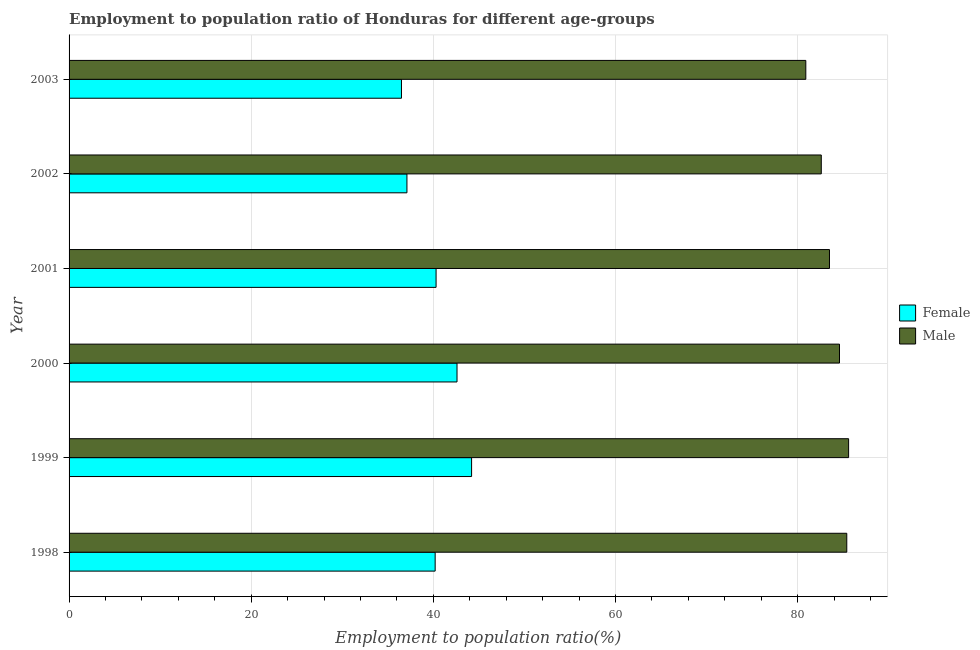How many different coloured bars are there?
Ensure brevity in your answer.  2. How many groups of bars are there?
Offer a terse response. 6. Are the number of bars per tick equal to the number of legend labels?
Offer a very short reply. Yes. How many bars are there on the 6th tick from the top?
Ensure brevity in your answer.  2. In how many cases, is the number of bars for a given year not equal to the number of legend labels?
Ensure brevity in your answer.  0. What is the employment to population ratio(male) in 1998?
Offer a terse response. 85.4. Across all years, what is the maximum employment to population ratio(female)?
Provide a succinct answer. 44.2. Across all years, what is the minimum employment to population ratio(female)?
Your answer should be compact. 36.5. In which year was the employment to population ratio(female) minimum?
Provide a succinct answer. 2003. What is the total employment to population ratio(male) in the graph?
Provide a short and direct response. 502.6. What is the difference between the employment to population ratio(male) in 2002 and that in 2003?
Ensure brevity in your answer.  1.7. What is the difference between the employment to population ratio(male) in 1998 and the employment to population ratio(female) in 1999?
Your response must be concise. 41.2. What is the average employment to population ratio(female) per year?
Keep it short and to the point. 40.15. In the year 2003, what is the difference between the employment to population ratio(female) and employment to population ratio(male)?
Offer a terse response. -44.4. Is the employment to population ratio(male) in 2000 less than that in 2002?
Your answer should be very brief. No. Is the difference between the employment to population ratio(female) in 2001 and 2003 greater than the difference between the employment to population ratio(male) in 2001 and 2003?
Provide a short and direct response. Yes. What is the difference between the highest and the lowest employment to population ratio(female)?
Your response must be concise. 7.7. Is the sum of the employment to population ratio(male) in 2002 and 2003 greater than the maximum employment to population ratio(female) across all years?
Your response must be concise. Yes. What does the 2nd bar from the top in 2003 represents?
Your answer should be very brief. Female. How many years are there in the graph?
Your response must be concise. 6. What is the difference between two consecutive major ticks on the X-axis?
Your response must be concise. 20. Does the graph contain any zero values?
Offer a very short reply. No. Does the graph contain grids?
Your response must be concise. Yes. Where does the legend appear in the graph?
Ensure brevity in your answer.  Center right. How are the legend labels stacked?
Make the answer very short. Vertical. What is the title of the graph?
Offer a very short reply. Employment to population ratio of Honduras for different age-groups. What is the label or title of the X-axis?
Your response must be concise. Employment to population ratio(%). What is the Employment to population ratio(%) of Female in 1998?
Provide a short and direct response. 40.2. What is the Employment to population ratio(%) in Male in 1998?
Your answer should be very brief. 85.4. What is the Employment to population ratio(%) in Female in 1999?
Ensure brevity in your answer.  44.2. What is the Employment to population ratio(%) in Male in 1999?
Keep it short and to the point. 85.6. What is the Employment to population ratio(%) of Female in 2000?
Offer a very short reply. 42.6. What is the Employment to population ratio(%) of Male in 2000?
Your answer should be compact. 84.6. What is the Employment to population ratio(%) in Female in 2001?
Provide a short and direct response. 40.3. What is the Employment to population ratio(%) of Male in 2001?
Give a very brief answer. 83.5. What is the Employment to population ratio(%) of Female in 2002?
Keep it short and to the point. 37.1. What is the Employment to population ratio(%) of Male in 2002?
Keep it short and to the point. 82.6. What is the Employment to population ratio(%) of Female in 2003?
Keep it short and to the point. 36.5. What is the Employment to population ratio(%) in Male in 2003?
Your response must be concise. 80.9. Across all years, what is the maximum Employment to population ratio(%) of Female?
Offer a terse response. 44.2. Across all years, what is the maximum Employment to population ratio(%) in Male?
Your answer should be very brief. 85.6. Across all years, what is the minimum Employment to population ratio(%) of Female?
Offer a very short reply. 36.5. Across all years, what is the minimum Employment to population ratio(%) in Male?
Offer a terse response. 80.9. What is the total Employment to population ratio(%) in Female in the graph?
Provide a succinct answer. 240.9. What is the total Employment to population ratio(%) in Male in the graph?
Your answer should be compact. 502.6. What is the difference between the Employment to population ratio(%) of Female in 1998 and that in 1999?
Provide a succinct answer. -4. What is the difference between the Employment to population ratio(%) of Male in 1998 and that in 1999?
Provide a succinct answer. -0.2. What is the difference between the Employment to population ratio(%) in Female in 1998 and that in 2003?
Offer a terse response. 3.7. What is the difference between the Employment to population ratio(%) of Female in 1999 and that in 2000?
Offer a terse response. 1.6. What is the difference between the Employment to population ratio(%) in Female in 1999 and that in 2001?
Give a very brief answer. 3.9. What is the difference between the Employment to population ratio(%) in Male in 1999 and that in 2001?
Offer a very short reply. 2.1. What is the difference between the Employment to population ratio(%) of Female in 1999 and that in 2002?
Your response must be concise. 7.1. What is the difference between the Employment to population ratio(%) of Male in 1999 and that in 2003?
Give a very brief answer. 4.7. What is the difference between the Employment to population ratio(%) of Female in 2000 and that in 2001?
Ensure brevity in your answer.  2.3. What is the difference between the Employment to population ratio(%) of Male in 2000 and that in 2001?
Your answer should be compact. 1.1. What is the difference between the Employment to population ratio(%) of Female in 2000 and that in 2003?
Your answer should be very brief. 6.1. What is the difference between the Employment to population ratio(%) in Female in 2001 and that in 2002?
Make the answer very short. 3.2. What is the difference between the Employment to population ratio(%) in Female in 2001 and that in 2003?
Provide a short and direct response. 3.8. What is the difference between the Employment to population ratio(%) of Male in 2001 and that in 2003?
Offer a very short reply. 2.6. What is the difference between the Employment to population ratio(%) of Female in 2002 and that in 2003?
Ensure brevity in your answer.  0.6. What is the difference between the Employment to population ratio(%) of Male in 2002 and that in 2003?
Give a very brief answer. 1.7. What is the difference between the Employment to population ratio(%) in Female in 1998 and the Employment to population ratio(%) in Male in 1999?
Your answer should be compact. -45.4. What is the difference between the Employment to population ratio(%) of Female in 1998 and the Employment to population ratio(%) of Male in 2000?
Provide a short and direct response. -44.4. What is the difference between the Employment to population ratio(%) of Female in 1998 and the Employment to population ratio(%) of Male in 2001?
Provide a succinct answer. -43.3. What is the difference between the Employment to population ratio(%) in Female in 1998 and the Employment to population ratio(%) in Male in 2002?
Keep it short and to the point. -42.4. What is the difference between the Employment to population ratio(%) of Female in 1998 and the Employment to population ratio(%) of Male in 2003?
Make the answer very short. -40.7. What is the difference between the Employment to population ratio(%) in Female in 1999 and the Employment to population ratio(%) in Male in 2000?
Provide a short and direct response. -40.4. What is the difference between the Employment to population ratio(%) of Female in 1999 and the Employment to population ratio(%) of Male in 2001?
Provide a succinct answer. -39.3. What is the difference between the Employment to population ratio(%) of Female in 1999 and the Employment to population ratio(%) of Male in 2002?
Keep it short and to the point. -38.4. What is the difference between the Employment to population ratio(%) of Female in 1999 and the Employment to population ratio(%) of Male in 2003?
Give a very brief answer. -36.7. What is the difference between the Employment to population ratio(%) in Female in 2000 and the Employment to population ratio(%) in Male in 2001?
Your response must be concise. -40.9. What is the difference between the Employment to population ratio(%) in Female in 2000 and the Employment to population ratio(%) in Male in 2002?
Provide a short and direct response. -40. What is the difference between the Employment to population ratio(%) in Female in 2000 and the Employment to population ratio(%) in Male in 2003?
Give a very brief answer. -38.3. What is the difference between the Employment to population ratio(%) of Female in 2001 and the Employment to population ratio(%) of Male in 2002?
Your response must be concise. -42.3. What is the difference between the Employment to population ratio(%) in Female in 2001 and the Employment to population ratio(%) in Male in 2003?
Keep it short and to the point. -40.6. What is the difference between the Employment to population ratio(%) of Female in 2002 and the Employment to population ratio(%) of Male in 2003?
Your response must be concise. -43.8. What is the average Employment to population ratio(%) of Female per year?
Give a very brief answer. 40.15. What is the average Employment to population ratio(%) of Male per year?
Keep it short and to the point. 83.77. In the year 1998, what is the difference between the Employment to population ratio(%) in Female and Employment to population ratio(%) in Male?
Offer a terse response. -45.2. In the year 1999, what is the difference between the Employment to population ratio(%) in Female and Employment to population ratio(%) in Male?
Make the answer very short. -41.4. In the year 2000, what is the difference between the Employment to population ratio(%) of Female and Employment to population ratio(%) of Male?
Offer a very short reply. -42. In the year 2001, what is the difference between the Employment to population ratio(%) of Female and Employment to population ratio(%) of Male?
Provide a short and direct response. -43.2. In the year 2002, what is the difference between the Employment to population ratio(%) of Female and Employment to population ratio(%) of Male?
Offer a very short reply. -45.5. In the year 2003, what is the difference between the Employment to population ratio(%) in Female and Employment to population ratio(%) in Male?
Offer a very short reply. -44.4. What is the ratio of the Employment to population ratio(%) in Female in 1998 to that in 1999?
Your response must be concise. 0.91. What is the ratio of the Employment to population ratio(%) in Male in 1998 to that in 1999?
Your response must be concise. 1. What is the ratio of the Employment to population ratio(%) in Female in 1998 to that in 2000?
Offer a terse response. 0.94. What is the ratio of the Employment to population ratio(%) in Male in 1998 to that in 2000?
Offer a very short reply. 1.01. What is the ratio of the Employment to population ratio(%) of Male in 1998 to that in 2001?
Keep it short and to the point. 1.02. What is the ratio of the Employment to population ratio(%) in Female in 1998 to that in 2002?
Provide a succinct answer. 1.08. What is the ratio of the Employment to population ratio(%) in Male in 1998 to that in 2002?
Offer a terse response. 1.03. What is the ratio of the Employment to population ratio(%) in Female in 1998 to that in 2003?
Give a very brief answer. 1.1. What is the ratio of the Employment to population ratio(%) of Male in 1998 to that in 2003?
Your answer should be very brief. 1.06. What is the ratio of the Employment to population ratio(%) of Female in 1999 to that in 2000?
Offer a terse response. 1.04. What is the ratio of the Employment to population ratio(%) in Male in 1999 to that in 2000?
Provide a short and direct response. 1.01. What is the ratio of the Employment to population ratio(%) of Female in 1999 to that in 2001?
Keep it short and to the point. 1.1. What is the ratio of the Employment to population ratio(%) of Male in 1999 to that in 2001?
Offer a very short reply. 1.03. What is the ratio of the Employment to population ratio(%) of Female in 1999 to that in 2002?
Your response must be concise. 1.19. What is the ratio of the Employment to population ratio(%) of Male in 1999 to that in 2002?
Offer a very short reply. 1.04. What is the ratio of the Employment to population ratio(%) in Female in 1999 to that in 2003?
Your response must be concise. 1.21. What is the ratio of the Employment to population ratio(%) in Male in 1999 to that in 2003?
Keep it short and to the point. 1.06. What is the ratio of the Employment to population ratio(%) in Female in 2000 to that in 2001?
Your answer should be compact. 1.06. What is the ratio of the Employment to population ratio(%) of Male in 2000 to that in 2001?
Offer a terse response. 1.01. What is the ratio of the Employment to population ratio(%) of Female in 2000 to that in 2002?
Ensure brevity in your answer.  1.15. What is the ratio of the Employment to population ratio(%) in Male in 2000 to that in 2002?
Your response must be concise. 1.02. What is the ratio of the Employment to population ratio(%) in Female in 2000 to that in 2003?
Offer a very short reply. 1.17. What is the ratio of the Employment to population ratio(%) of Male in 2000 to that in 2003?
Give a very brief answer. 1.05. What is the ratio of the Employment to population ratio(%) of Female in 2001 to that in 2002?
Keep it short and to the point. 1.09. What is the ratio of the Employment to population ratio(%) in Male in 2001 to that in 2002?
Offer a very short reply. 1.01. What is the ratio of the Employment to population ratio(%) of Female in 2001 to that in 2003?
Offer a very short reply. 1.1. What is the ratio of the Employment to population ratio(%) in Male in 2001 to that in 2003?
Your response must be concise. 1.03. What is the ratio of the Employment to population ratio(%) of Female in 2002 to that in 2003?
Ensure brevity in your answer.  1.02. What is the difference between the highest and the second highest Employment to population ratio(%) of Female?
Keep it short and to the point. 1.6. What is the difference between the highest and the lowest Employment to population ratio(%) in Female?
Your answer should be very brief. 7.7. What is the difference between the highest and the lowest Employment to population ratio(%) in Male?
Make the answer very short. 4.7. 